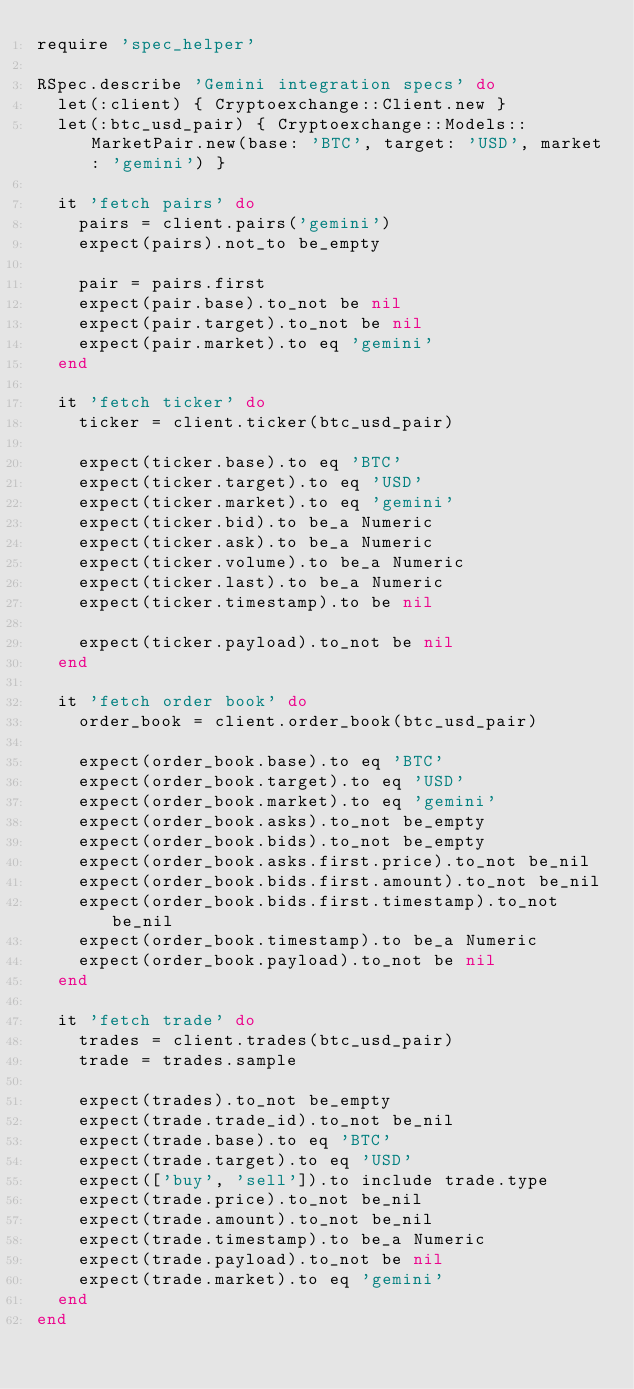Convert code to text. <code><loc_0><loc_0><loc_500><loc_500><_Ruby_>require 'spec_helper'

RSpec.describe 'Gemini integration specs' do
  let(:client) { Cryptoexchange::Client.new }
  let(:btc_usd_pair) { Cryptoexchange::Models::MarketPair.new(base: 'BTC', target: 'USD', market: 'gemini') }

  it 'fetch pairs' do
    pairs = client.pairs('gemini')
    expect(pairs).not_to be_empty

    pair = pairs.first
    expect(pair.base).to_not be nil
    expect(pair.target).to_not be nil
    expect(pair.market).to eq 'gemini'
  end

  it 'fetch ticker' do
    ticker = client.ticker(btc_usd_pair)

    expect(ticker.base).to eq 'BTC'
    expect(ticker.target).to eq 'USD'
    expect(ticker.market).to eq 'gemini'
    expect(ticker.bid).to be_a Numeric
    expect(ticker.ask).to be_a Numeric
    expect(ticker.volume).to be_a Numeric
    expect(ticker.last).to be_a Numeric
    expect(ticker.timestamp).to be nil
    
    expect(ticker.payload).to_not be nil
  end

  it 'fetch order book' do
    order_book = client.order_book(btc_usd_pair)

    expect(order_book.base).to eq 'BTC'
    expect(order_book.target).to eq 'USD'
    expect(order_book.market).to eq 'gemini'
    expect(order_book.asks).to_not be_empty
    expect(order_book.bids).to_not be_empty
    expect(order_book.asks.first.price).to_not be_nil
    expect(order_book.bids.first.amount).to_not be_nil
    expect(order_book.bids.first.timestamp).to_not be_nil
    expect(order_book.timestamp).to be_a Numeric
    expect(order_book.payload).to_not be nil
  end

  it 'fetch trade' do
    trades = client.trades(btc_usd_pair)
    trade = trades.sample

    expect(trades).to_not be_empty
    expect(trade.trade_id).to_not be_nil
    expect(trade.base).to eq 'BTC'
    expect(trade.target).to eq 'USD'
    expect(['buy', 'sell']).to include trade.type
    expect(trade.price).to_not be_nil
    expect(trade.amount).to_not be_nil
    expect(trade.timestamp).to be_a Numeric
    expect(trade.payload).to_not be nil
    expect(trade.market).to eq 'gemini'
  end
end
</code> 